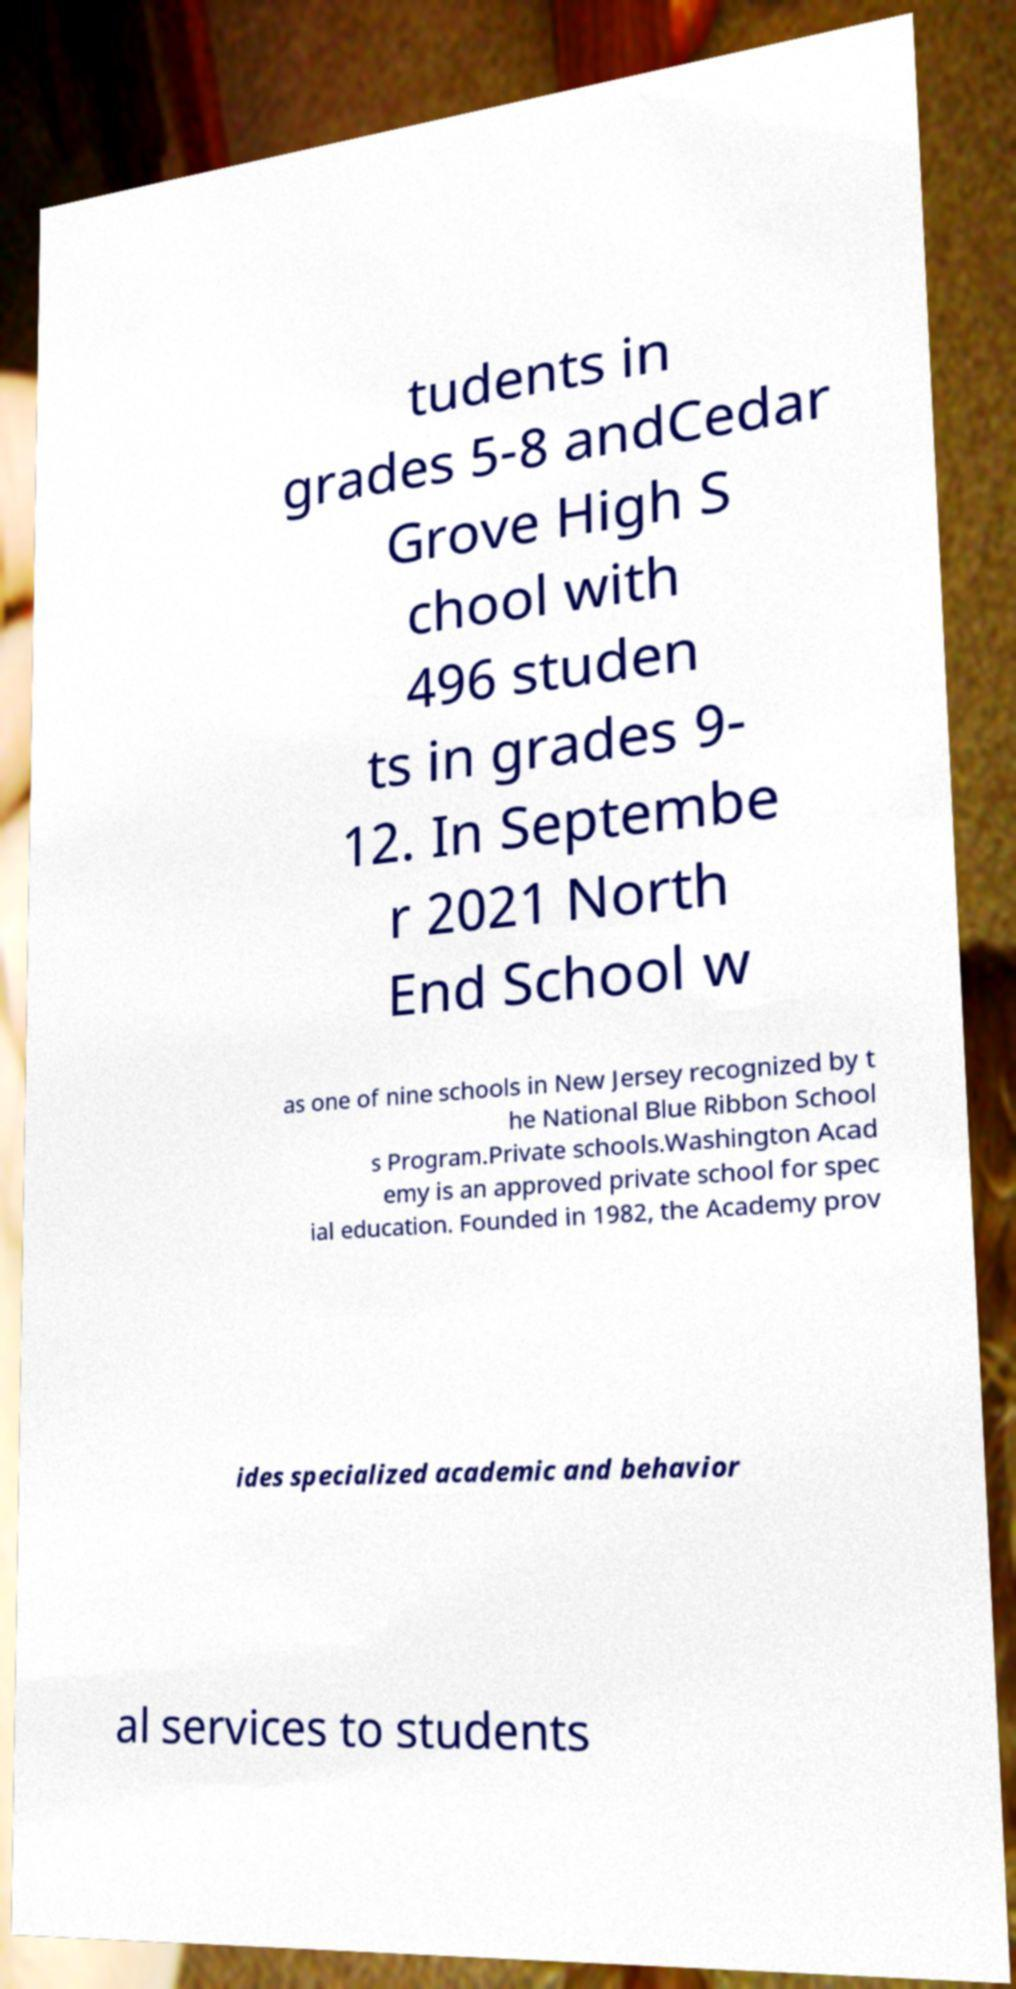I need the written content from this picture converted into text. Can you do that? tudents in grades 5-8 andCedar Grove High S chool with 496 studen ts in grades 9- 12. In Septembe r 2021 North End School w as one of nine schools in New Jersey recognized by t he National Blue Ribbon School s Program.Private schools.Washington Acad emy is an approved private school for spec ial education. Founded in 1982, the Academy prov ides specialized academic and behavior al services to students 